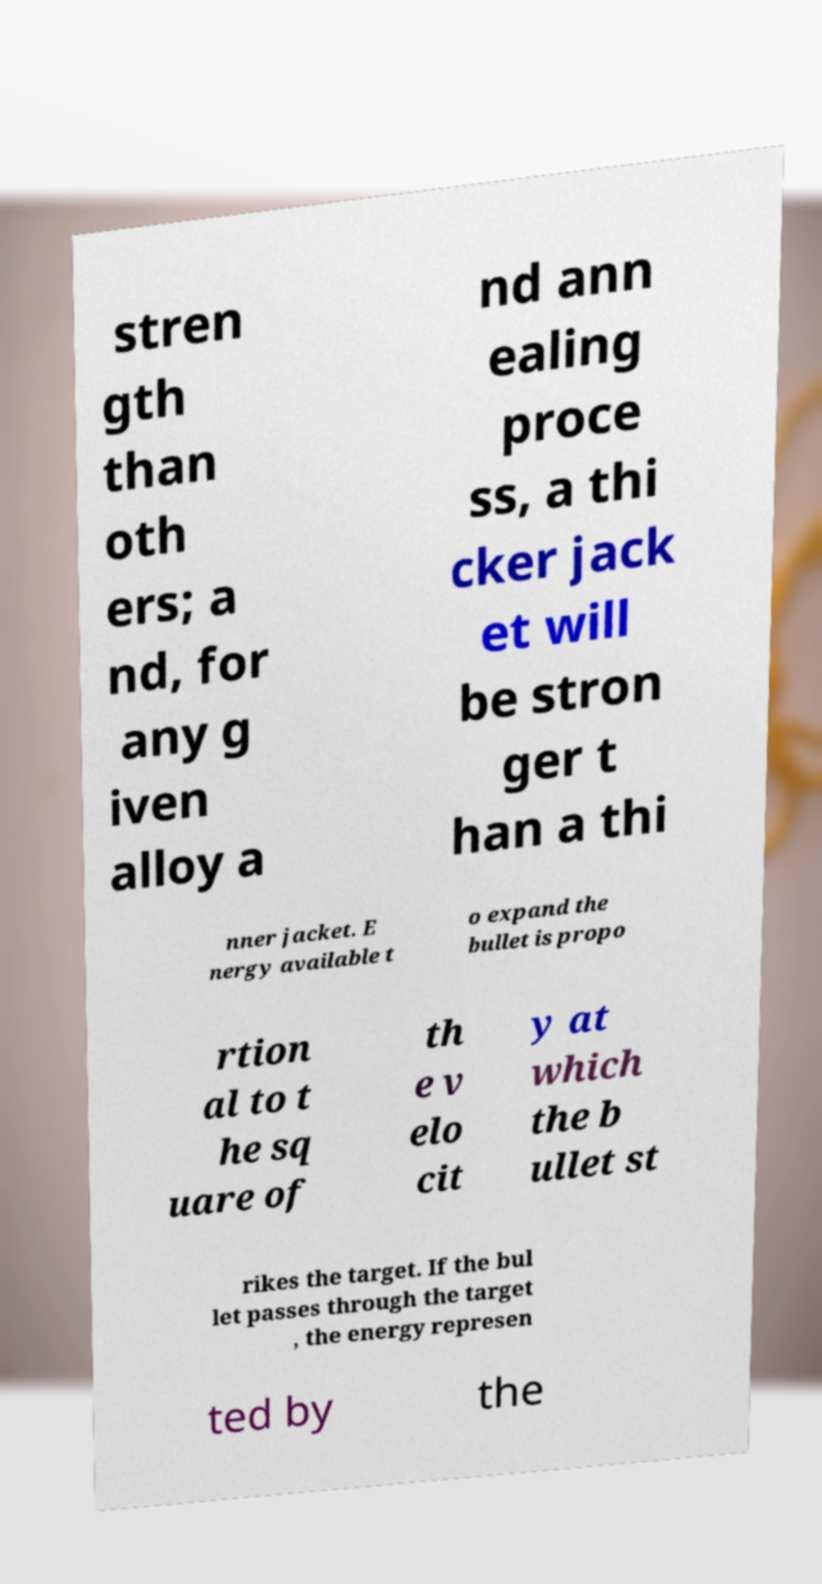I need the written content from this picture converted into text. Can you do that? stren gth than oth ers; a nd, for any g iven alloy a nd ann ealing proce ss, a thi cker jack et will be stron ger t han a thi nner jacket. E nergy available t o expand the bullet is propo rtion al to t he sq uare of th e v elo cit y at which the b ullet st rikes the target. If the bul let passes through the target , the energy represen ted by the 